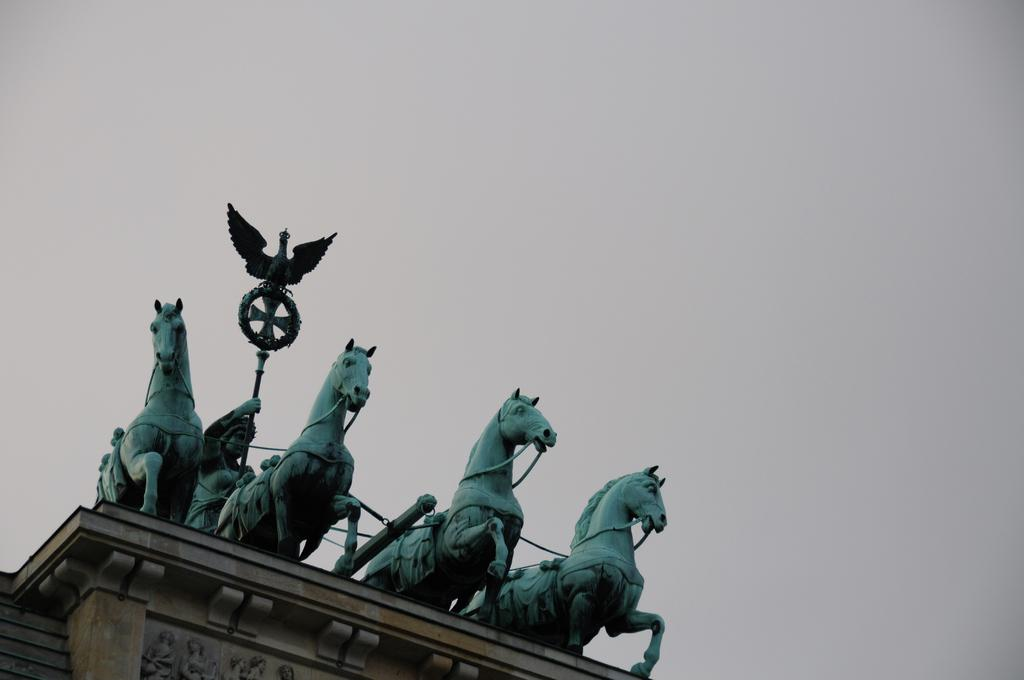What type of statues can be seen in the image? There are statues of horses and a man in the image. Can you describe the sky in the image? The sky is cloudy in the image. How many engines can be seen on the bikes in the image? There are no bikes present in the image, so there are no engines to count. 